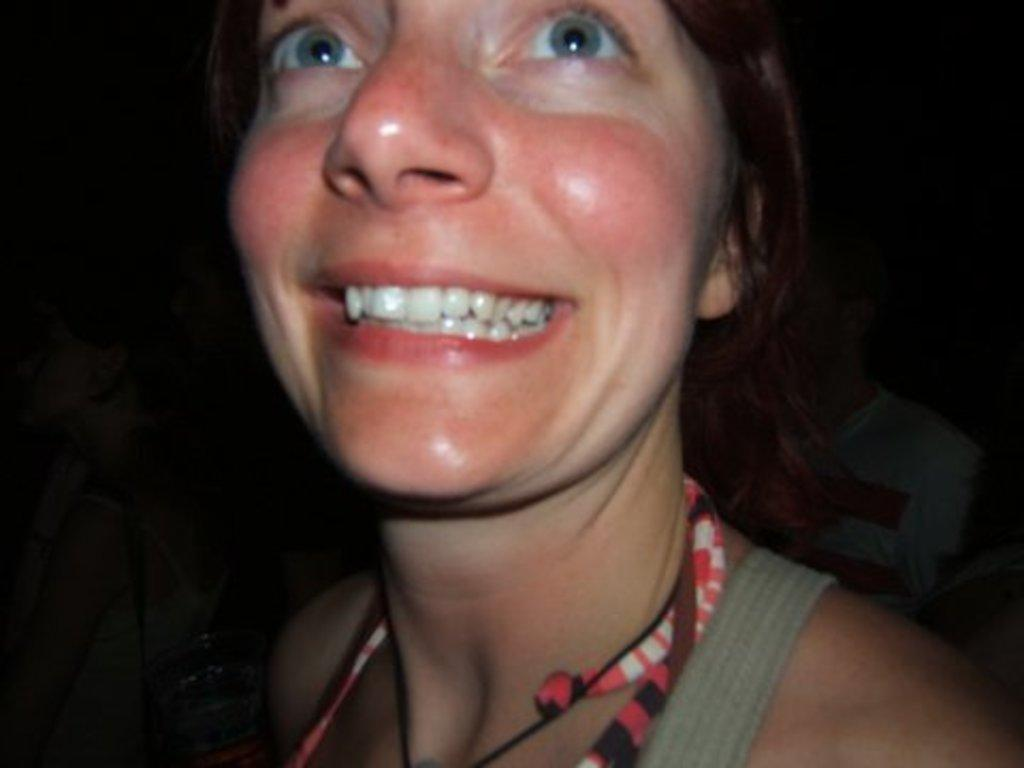Who is present in the image? There is a person in the image. What is the person doing in the image? The person is smiling. How many other people are in the image besides the smiling person? There are two other people in the image. What can be observed about the lighting or color of the image? The backdrop of the image is dark. What type of pin is visible on the person's shirt in the image? There is no pin visible on the person's shirt in the image. Where is the camp located in the image? There is no camp present in the image. 